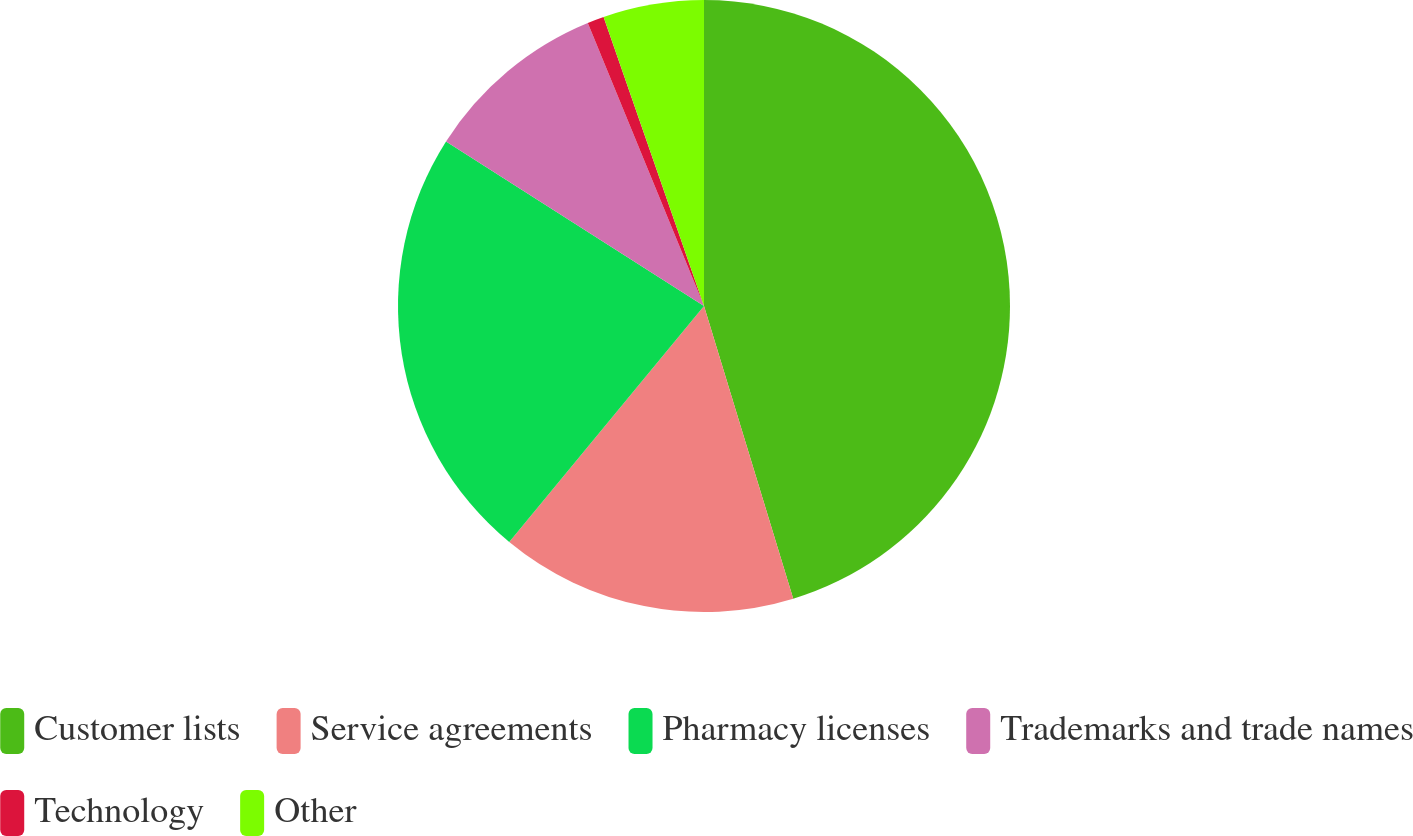<chart> <loc_0><loc_0><loc_500><loc_500><pie_chart><fcel>Customer lists<fcel>Service agreements<fcel>Pharmacy licenses<fcel>Trademarks and trade names<fcel>Technology<fcel>Other<nl><fcel>45.29%<fcel>15.69%<fcel>23.06%<fcel>9.76%<fcel>0.88%<fcel>5.32%<nl></chart> 